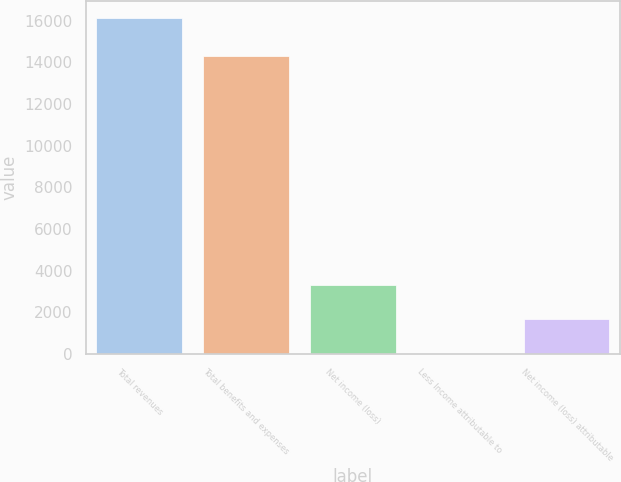<chart> <loc_0><loc_0><loc_500><loc_500><bar_chart><fcel>Total revenues<fcel>Total benefits and expenses<fcel>Net income (loss)<fcel>Less Income attributable to<fcel>Net income (loss) attributable<nl><fcel>16148<fcel>14310<fcel>3286.5<fcel>3<fcel>1672<nl></chart> 